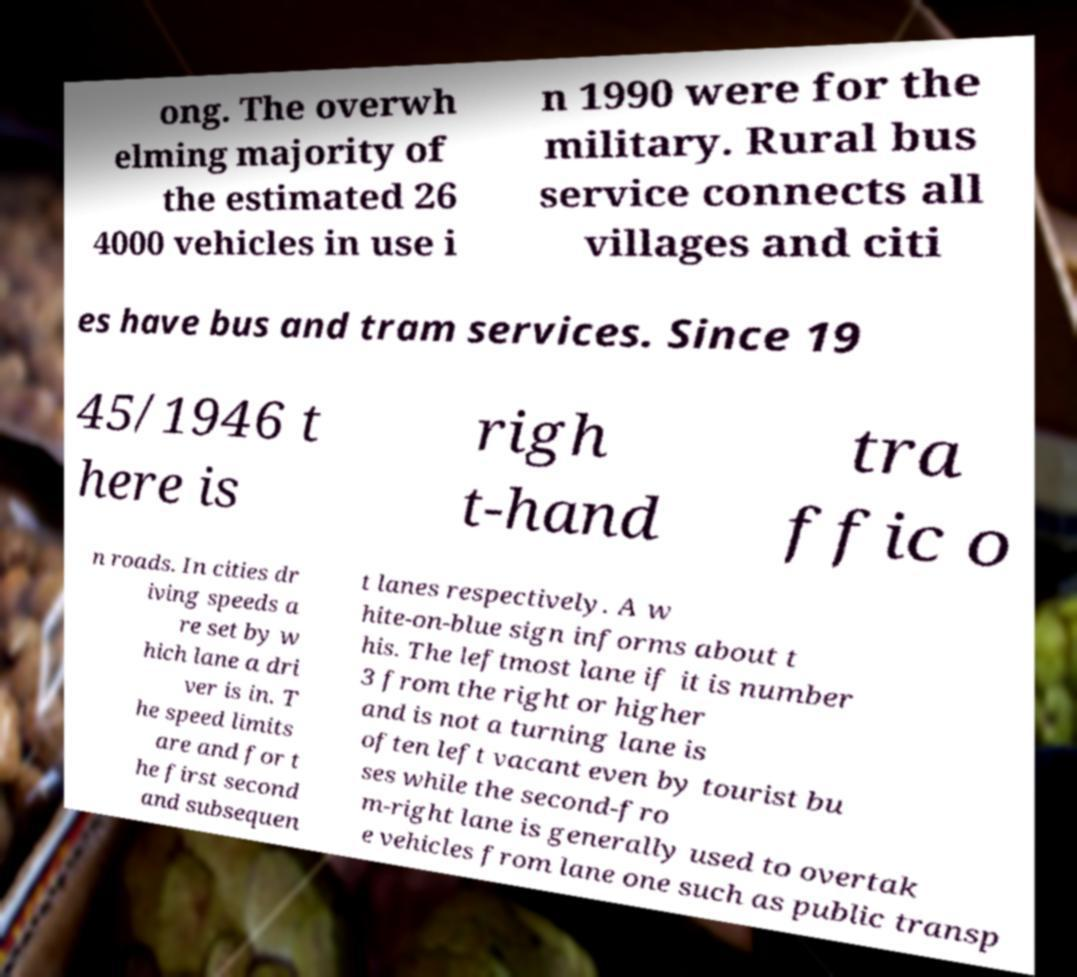What messages or text are displayed in this image? I need them in a readable, typed format. ong. The overwh elming majority of the estimated 26 4000 vehicles in use i n 1990 were for the military. Rural bus service connects all villages and citi es have bus and tram services. Since 19 45/1946 t here is righ t-hand tra ffic o n roads. In cities dr iving speeds a re set by w hich lane a dri ver is in. T he speed limits are and for t he first second and subsequen t lanes respectively. A w hite-on-blue sign informs about t his. The leftmost lane if it is number 3 from the right or higher and is not a turning lane is often left vacant even by tourist bu ses while the second-fro m-right lane is generally used to overtak e vehicles from lane one such as public transp 